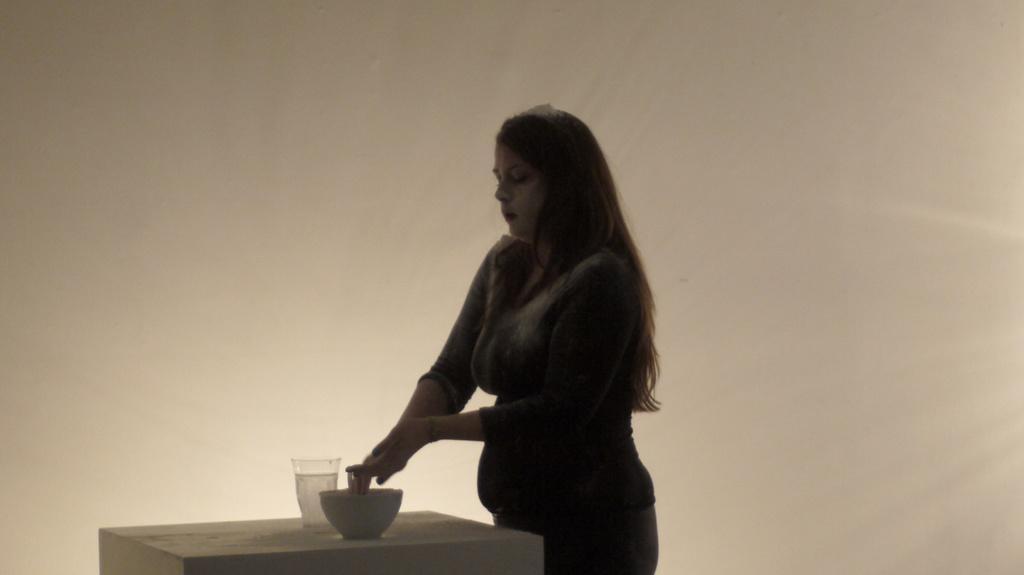In one or two sentences, can you explain what this image depicts? In this image I see a woman who is standing and I see a table over here on which there is a bowl and a glass and I see it is cream color in the background. 